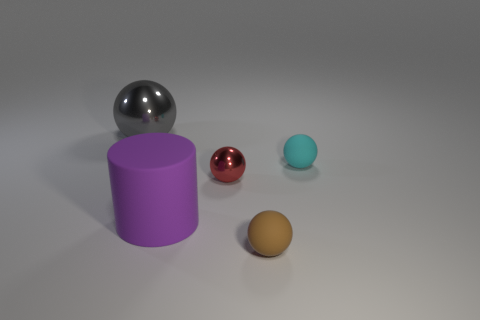Add 1 tiny blue metal balls. How many objects exist? 6 Subtract all cylinders. How many objects are left? 4 Subtract all tiny cyan matte objects. Subtract all blue cubes. How many objects are left? 4 Add 1 red things. How many red things are left? 2 Add 2 green balls. How many green balls exist? 2 Subtract 0 blue balls. How many objects are left? 5 